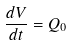<formula> <loc_0><loc_0><loc_500><loc_500>\frac { d V } { d t } = Q _ { 0 }</formula> 